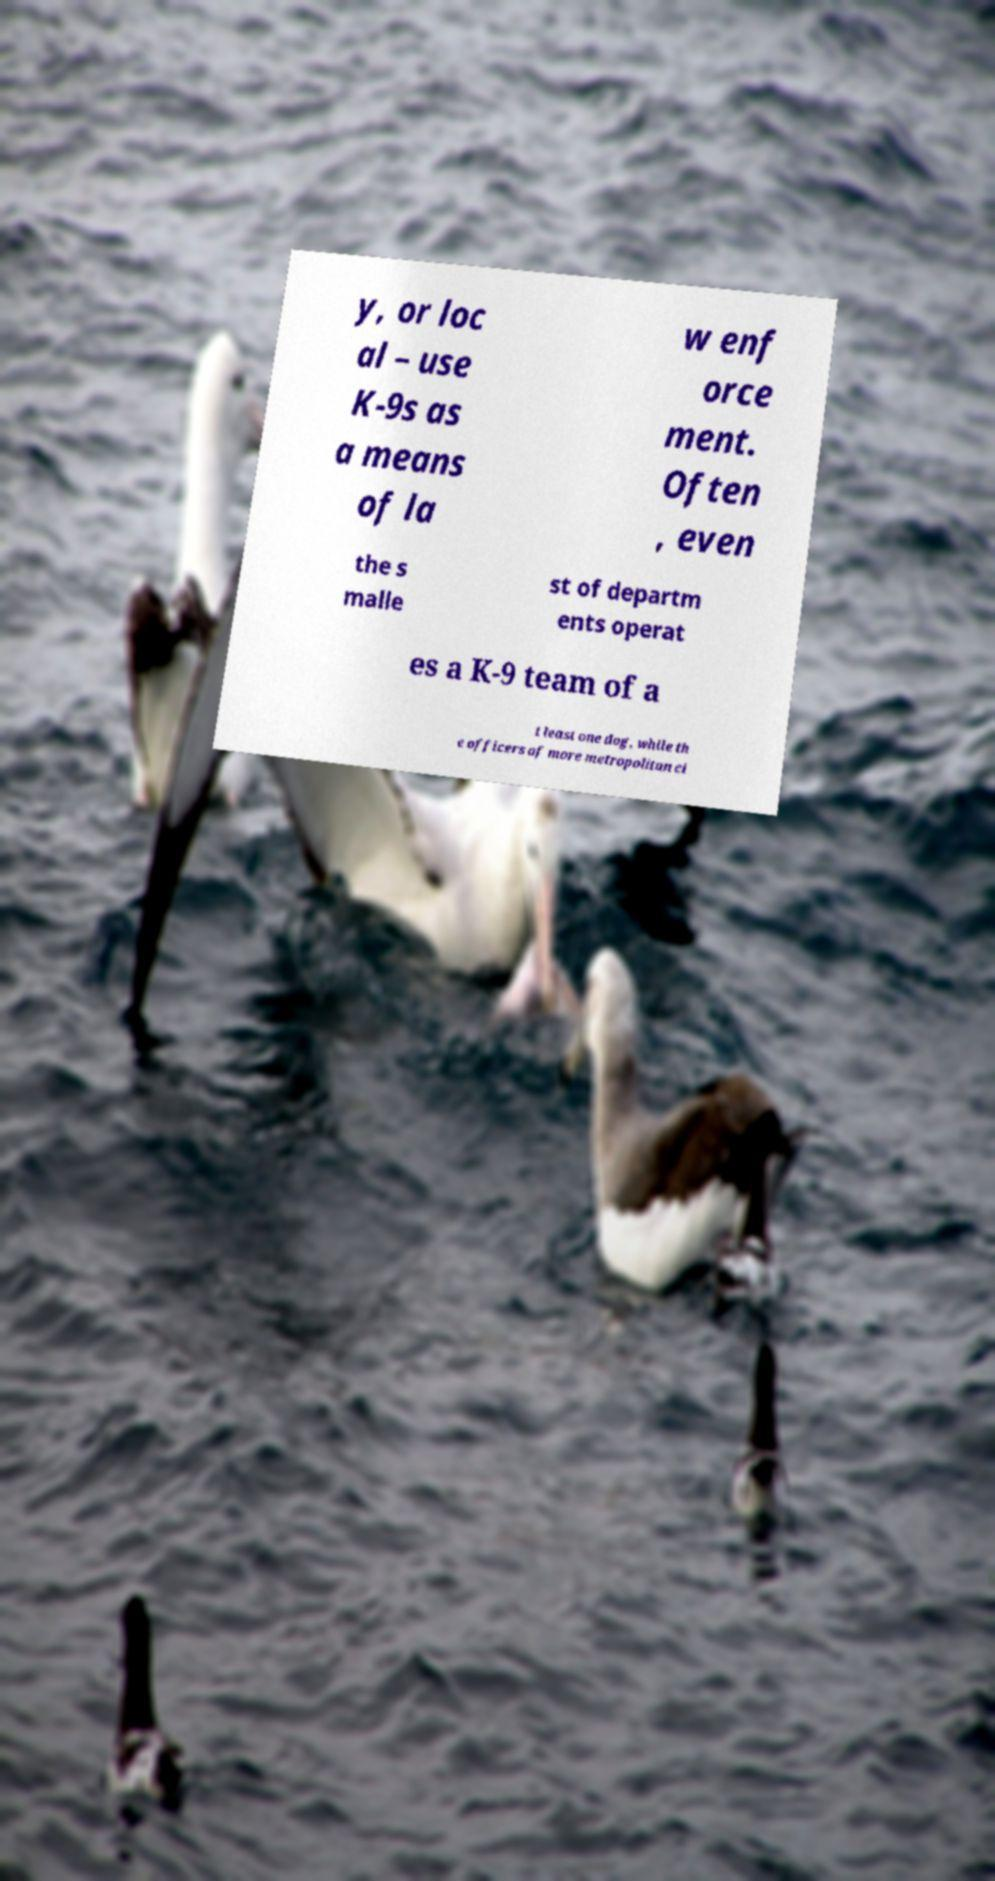For documentation purposes, I need the text within this image transcribed. Could you provide that? y, or loc al – use K-9s as a means of la w enf orce ment. Often , even the s malle st of departm ents operat es a K-9 team of a t least one dog, while th e officers of more metropolitan ci 